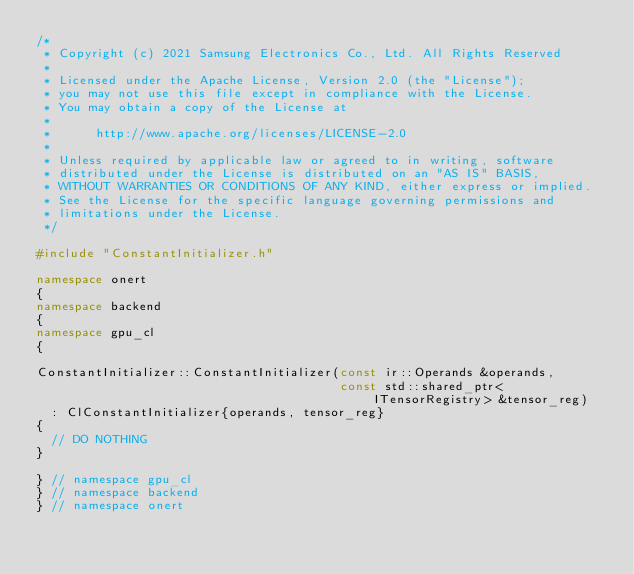<code> <loc_0><loc_0><loc_500><loc_500><_C++_>/*
 * Copyright (c) 2021 Samsung Electronics Co., Ltd. All Rights Reserved
 *
 * Licensed under the Apache License, Version 2.0 (the "License");
 * you may not use this file except in compliance with the License.
 * You may obtain a copy of the License at
 *
 *      http://www.apache.org/licenses/LICENSE-2.0
 *
 * Unless required by applicable law or agreed to in writing, software
 * distributed under the License is distributed on an "AS IS" BASIS,
 * WITHOUT WARRANTIES OR CONDITIONS OF ANY KIND, either express or implied.
 * See the License for the specific language governing permissions and
 * limitations under the License.
 */

#include "ConstantInitializer.h"

namespace onert
{
namespace backend
{
namespace gpu_cl
{

ConstantInitializer::ConstantInitializer(const ir::Operands &operands,
                                         const std::shared_ptr<ITensorRegistry> &tensor_reg)
  : ClConstantInitializer{operands, tensor_reg}
{
  // DO NOTHING
}

} // namespace gpu_cl
} // namespace backend
} // namespace onert
</code> 